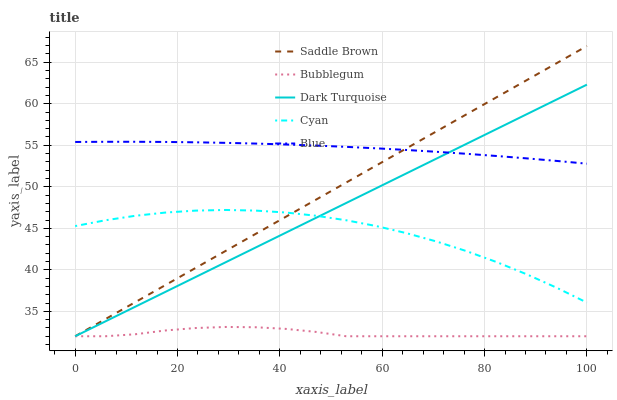Does Bubblegum have the minimum area under the curve?
Answer yes or no. Yes. Does Blue have the maximum area under the curve?
Answer yes or no. Yes. Does Dark Turquoise have the minimum area under the curve?
Answer yes or no. No. Does Dark Turquoise have the maximum area under the curve?
Answer yes or no. No. Is Dark Turquoise the smoothest?
Answer yes or no. Yes. Is Cyan the roughest?
Answer yes or no. Yes. Is Saddle Brown the smoothest?
Answer yes or no. No. Is Saddle Brown the roughest?
Answer yes or no. No. Does Dark Turquoise have the lowest value?
Answer yes or no. Yes. Does Cyan have the lowest value?
Answer yes or no. No. Does Saddle Brown have the highest value?
Answer yes or no. Yes. Does Dark Turquoise have the highest value?
Answer yes or no. No. Is Bubblegum less than Blue?
Answer yes or no. Yes. Is Blue greater than Cyan?
Answer yes or no. Yes. Does Dark Turquoise intersect Blue?
Answer yes or no. Yes. Is Dark Turquoise less than Blue?
Answer yes or no. No. Is Dark Turquoise greater than Blue?
Answer yes or no. No. Does Bubblegum intersect Blue?
Answer yes or no. No. 